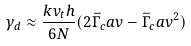Convert formula to latex. <formula><loc_0><loc_0><loc_500><loc_500>\gamma _ { d } \approx \frac { k v _ { t } h } { 6 N } ( 2 \bar { \Gamma } _ { c } a v - \bar { \Gamma } _ { c } a v ^ { 2 } )</formula> 